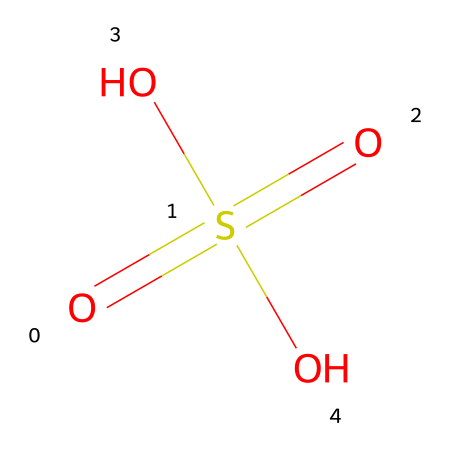What is the molecular formula of this compound? The SMILES structure indicates it contains one sulfur (S) atom, four oxygen (O) atoms, and two hydrogen (H) atoms, leading to the molecular formula H2SO4.
Answer: H2SO4 How many oxygen atoms are present in this molecule? By analyzing the SMILES representation, we can see that there are four oxygen atoms surrounding the sulfur atom, which can be counted directly.
Answer: 4 What type of acid is represented by this chemical? This compound is composed of hydrogen, sulfur, and oxygen, specifically containing the sulfate group; therefore, it is categorized as a strong acid known as sulfuric acid.
Answer: strong acid What is the charge of the sulfate ion derived from this compound? The chemical composition suggests that upon dissociation, the sulfate ion (SO4^2-) carries a negative two charge because the sulfur atom shares its electrons with four oxygen atoms, contributing to a valence of +6.
Answer: -2 How does this compound contribute to acid rain formation? Sulfuric acid (H2SO4) is formed when sulfur dioxide (SO2) reacts with water and oxygen in the atmosphere, contributing to acid rain, which occurs when acidic compounds fall to Earth through precipitation.
Answer: contributes to acid rain How many hydrogens are in the molecular structure? Looking at the provided SMILES representation, we can identify that there are two hydrogen atoms bonded to the sulfur atom within the molecule.
Answer: 2 What role does sulfuric acid play in the environment? Sulfuric acid acts as a pollutant when released into the atmosphere, promoting the formation of acid rain, which can damage ecosystems and infrastructure due to its corrosive properties.
Answer: pollutant 